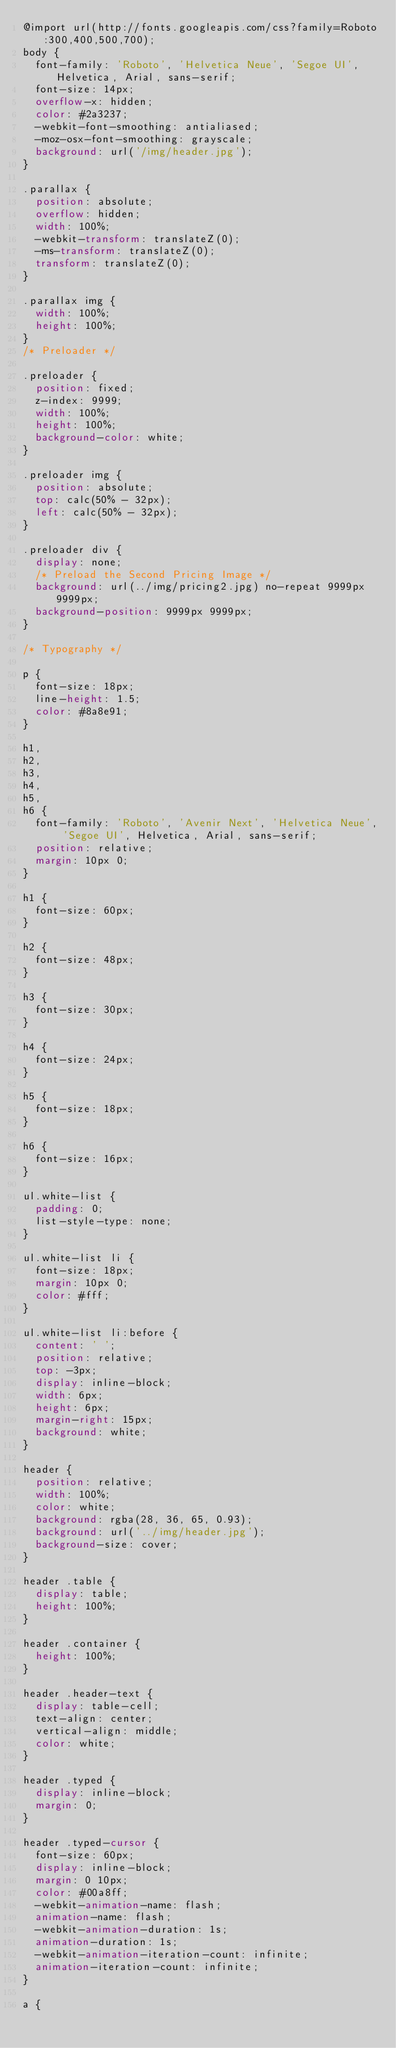Convert code to text. <code><loc_0><loc_0><loc_500><loc_500><_CSS_>@import url(http://fonts.googleapis.com/css?family=Roboto:300,400,500,700);
body {
	font-family: 'Roboto', 'Helvetica Neue', 'Segoe UI', Helvetica, Arial, sans-serif;
	font-size: 14px;
	overflow-x: hidden;
	color: #2a3237;
	-webkit-font-smoothing: antialiased;
	-moz-osx-font-smoothing: grayscale;
	background: url('/img/header.jpg');
}

.parallax {
	position: absolute;
	overflow: hidden;
	width: 100%;
	-webkit-transform: translateZ(0);
	-ms-transform: translateZ(0);
	transform: translateZ(0);
}

.parallax img {
	width: 100%;
	height: 100%;
}
/* Preloader */

.preloader {
	position: fixed;
	z-index: 9999;
	width: 100%;
	height: 100%;
	background-color: white;
}

.preloader img {
	position: absolute;
	top: calc(50% - 32px);
	left: calc(50% - 32px);
}

.preloader div {
	display: none;
	/* Preload the Second Pricing Image */
	background: url(../img/pricing2.jpg) no-repeat 9999px 9999px;
	background-position: 9999px 9999px;
}

/* Typography */

p {
	font-size: 18px;
	line-height: 1.5;
	color: #8a8e91;
}

h1,
h2,
h3,
h4,
h5,
h6 {
	font-family: 'Roboto', 'Avenir Next', 'Helvetica Neue', 'Segoe UI', Helvetica, Arial, sans-serif;
	position: relative;
	margin: 10px 0;
}

h1 {
	font-size: 60px;
}

h2 {
	font-size: 48px;
}

h3 {
	font-size: 30px;
}

h4 {
	font-size: 24px;
}

h5 {
	font-size: 18px;
}

h6 {
	font-size: 16px;
}

ul.white-list {
	padding: 0;
	list-style-type: none;
}

ul.white-list li {
	font-size: 18px;
	margin: 10px 0;
	color: #fff;
}

ul.white-list li:before {
	content: ' ';
	position: relative;
	top: -3px;
	display: inline-block;
	width: 6px;
	height: 6px;
	margin-right: 15px;
	background: white;
}

header {
	position: relative;
	width: 100%;
	color: white;
	background: rgba(28, 36, 65, 0.93);
	background: url('../img/header.jpg');
	background-size: cover;
}

header .table {
	display: table;
	height: 100%;
}

header .container {
	height: 100%;
}

header .header-text {
	display: table-cell;
	text-align: center;
	vertical-align: middle;
	color: white;
}

header .typed {
	display: inline-block;
	margin: 0;
}

header .typed-cursor {
	font-size: 60px;
	display: inline-block;
	margin: 0 10px;
	color: #00a8ff;
	-webkit-animation-name: flash;
	animation-name: flash;
	-webkit-animation-duration: 1s;
	animation-duration: 1s;
	-webkit-animation-iteration-count: infinite;
	animation-iteration-count: infinite;
}

a {</code> 